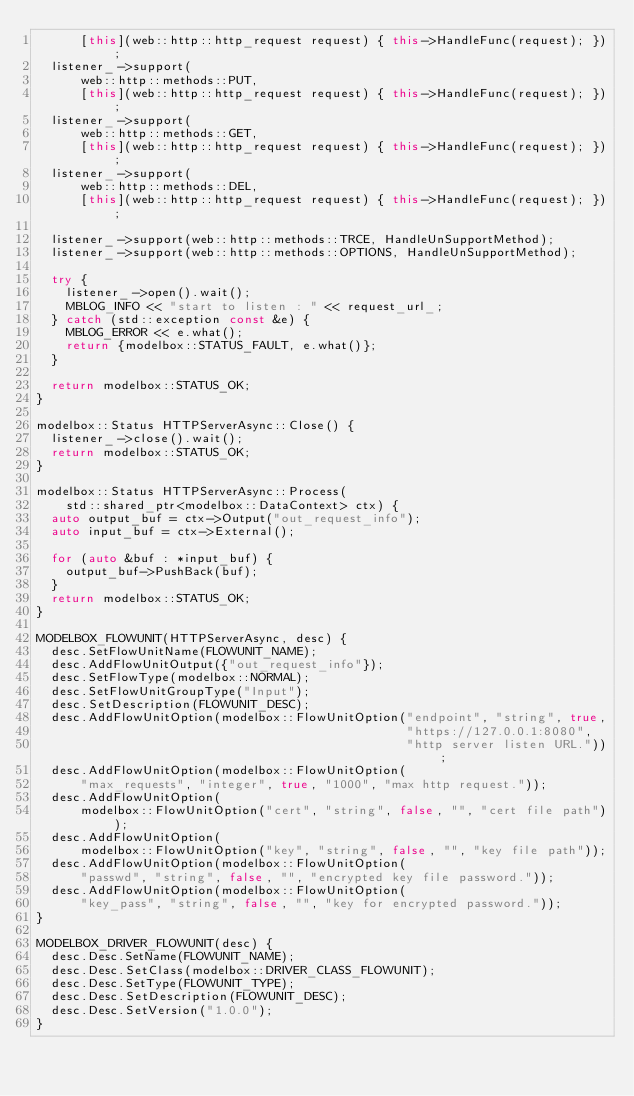Convert code to text. <code><loc_0><loc_0><loc_500><loc_500><_C++_>      [this](web::http::http_request request) { this->HandleFunc(request); });
  listener_->support(
      web::http::methods::PUT,
      [this](web::http::http_request request) { this->HandleFunc(request); });
  listener_->support(
      web::http::methods::GET,
      [this](web::http::http_request request) { this->HandleFunc(request); });
  listener_->support(
      web::http::methods::DEL,
      [this](web::http::http_request request) { this->HandleFunc(request); });

  listener_->support(web::http::methods::TRCE, HandleUnSupportMethod);
  listener_->support(web::http::methods::OPTIONS, HandleUnSupportMethod);

  try {
    listener_->open().wait();
    MBLOG_INFO << "start to listen : " << request_url_;
  } catch (std::exception const &e) {
    MBLOG_ERROR << e.what();
    return {modelbox::STATUS_FAULT, e.what()};
  }

  return modelbox::STATUS_OK;
}

modelbox::Status HTTPServerAsync::Close() {
  listener_->close().wait();
  return modelbox::STATUS_OK;
}

modelbox::Status HTTPServerAsync::Process(
    std::shared_ptr<modelbox::DataContext> ctx) {
  auto output_buf = ctx->Output("out_request_info");
  auto input_buf = ctx->External();

  for (auto &buf : *input_buf) {
    output_buf->PushBack(buf);
  }
  return modelbox::STATUS_OK;
}

MODELBOX_FLOWUNIT(HTTPServerAsync, desc) {
  desc.SetFlowUnitName(FLOWUNIT_NAME);
  desc.AddFlowUnitOutput({"out_request_info"});
  desc.SetFlowType(modelbox::NORMAL);
  desc.SetFlowUnitGroupType("Input");
  desc.SetDescription(FLOWUNIT_DESC);
  desc.AddFlowUnitOption(modelbox::FlowUnitOption("endpoint", "string", true,
                                                  "https://127.0.0.1:8080",
                                                  "http server listen URL."));
  desc.AddFlowUnitOption(modelbox::FlowUnitOption(
      "max_requests", "integer", true, "1000", "max http request."));
  desc.AddFlowUnitOption(
      modelbox::FlowUnitOption("cert", "string", false, "", "cert file path"));
  desc.AddFlowUnitOption(
      modelbox::FlowUnitOption("key", "string", false, "", "key file path"));
  desc.AddFlowUnitOption(modelbox::FlowUnitOption(
      "passwd", "string", false, "", "encrypted key file password."));
  desc.AddFlowUnitOption(modelbox::FlowUnitOption(
      "key_pass", "string", false, "", "key for encrypted password."));
}

MODELBOX_DRIVER_FLOWUNIT(desc) {
  desc.Desc.SetName(FLOWUNIT_NAME);
  desc.Desc.SetClass(modelbox::DRIVER_CLASS_FLOWUNIT);
  desc.Desc.SetType(FLOWUNIT_TYPE);
  desc.Desc.SetDescription(FLOWUNIT_DESC);
  desc.Desc.SetVersion("1.0.0");
}
</code> 